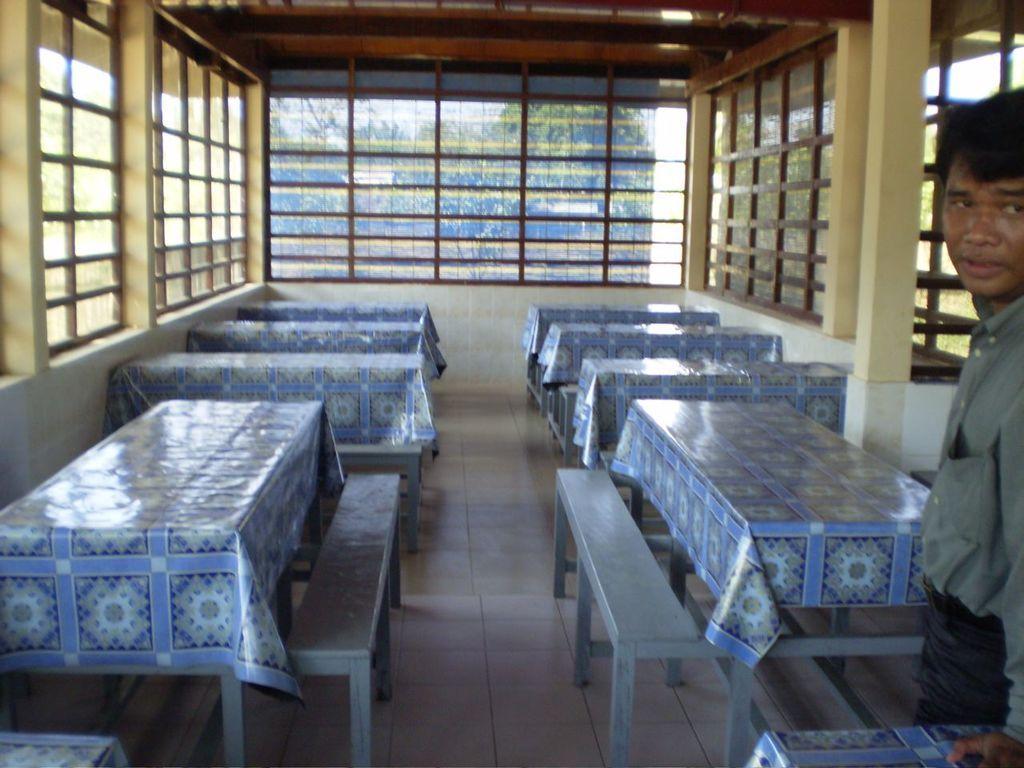Could you give a brief overview of what you see in this image? In this picture we can see the inside view of a room. These are the tables and there is a cover on the table. Here we can see a person standing beside the table. And this is the floor. 